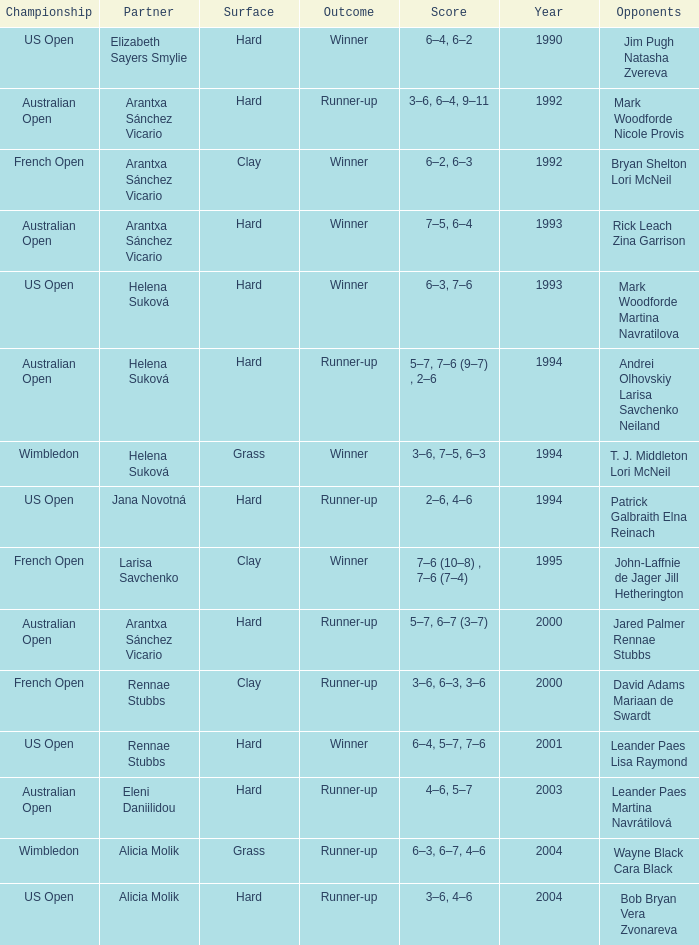Who was the Partner that was a winner, a Year smaller than 1993, and a Score of 6–4, 6–2? Elizabeth Sayers Smylie. 